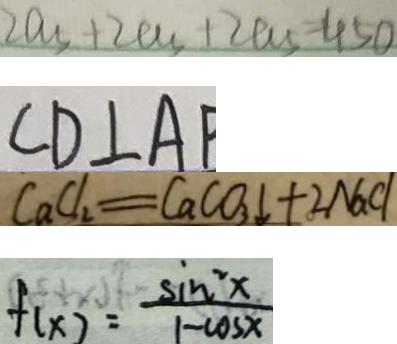<formula> <loc_0><loc_0><loc_500><loc_500>2 a _ { 5 } + 2 a _ { 5 } + 2 a _ { 5 } = 4 5 0 
 C D \bot A P 
 C a C _ { 2 } = C a C O _ { 3 } \downarrow + 2 N a C l 
 f ( x ) = \frac { \sin ^ { 2 } x } { 1 - \cos x }</formula> 